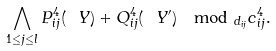Convert formula to latex. <formula><loc_0><loc_0><loc_500><loc_500>\bigwedge _ { 1 \leq j \leq l } P _ { i j } ^ { 4 } ( \ Y ) + Q _ { i j } ^ { 4 } ( \ Y ^ { \prime } ) \mod _ { d _ { i j } } c _ { i j } ^ { 4 } .</formula> 